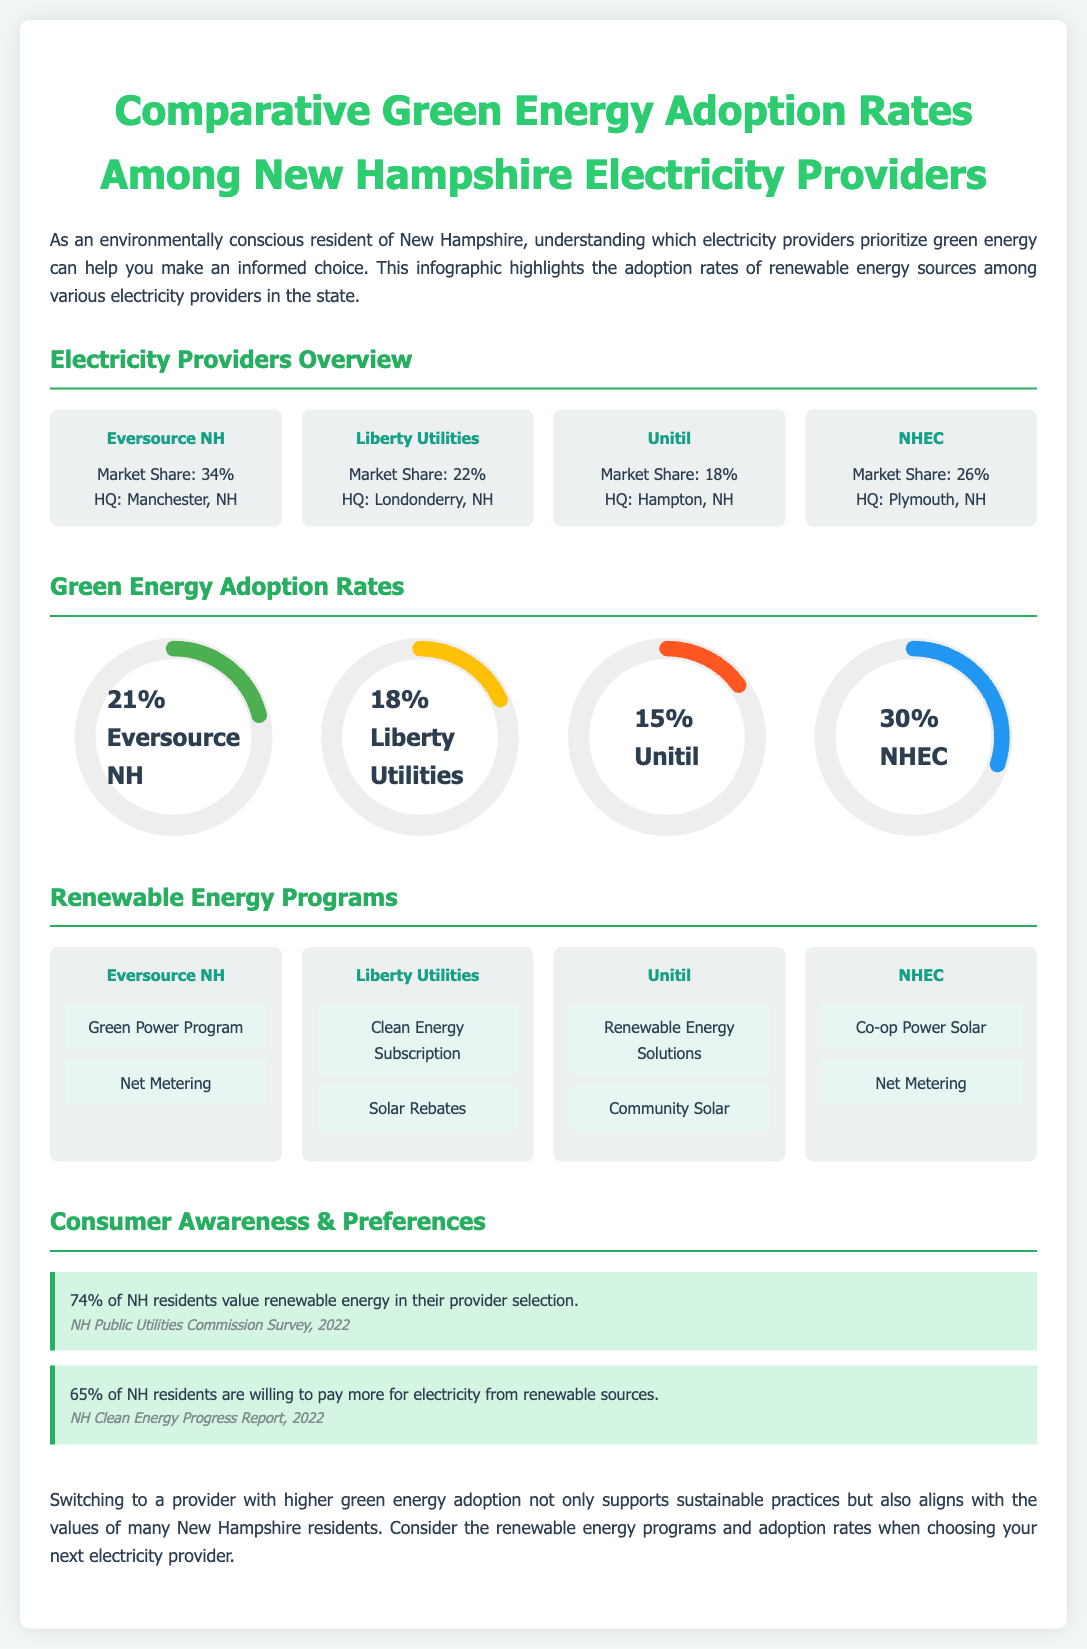What is the market share of Eversource NH? The market share of Eversource NH is shown as 34% in the provider overview section.
Answer: 34% What renewable energy program does Liberty Utilities offer? Liberty Utilities offers the "Clean Energy Subscription" as part of its renewable energy programs.
Answer: Clean Energy Subscription What percentage of residents are willing to pay more for renewable electricity? The document states that 65% of NH residents are willing to pay more for electricity from renewable sources.
Answer: 65% Who has the highest green energy adoption rate among providers? The green energy adoption rates indicate that NHEC has the highest rate at 30%.
Answer: NHEC How many renewable energy programs does Unitil have listed? Unitil has two renewable energy programs listed in the provider section.
Answer: 2 What is the green energy adoption percentage for Eversource NH? Eversource NH's green energy adoption percentage is displayed as 21% in the chart section.
Answer: 21% Which electricity provider has its headquarters in Hampton, NH? The document identifies Unitil as having its headquarters in Hampton, NH.
Answer: Unitil What color represents Liberty Utilities in the green energy chart? Liberty Utilities is represented in yellow in the green energy adoption chart.
Answer: Yellow 